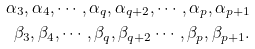<formula> <loc_0><loc_0><loc_500><loc_500>\alpha _ { 3 } , \alpha _ { 4 } , \cdots , \alpha _ { q } , \alpha _ { q + 2 } , \cdots , \alpha _ { p } , \alpha _ { p + 1 } \\ \beta _ { 3 } , \beta _ { 4 } , \cdots , \beta _ { q } , \beta _ { q + 2 } \cdots , \beta _ { p } , \beta _ { p + 1 } .</formula> 